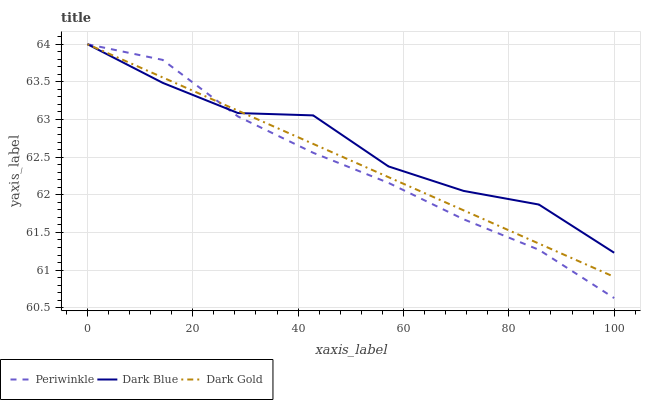Does Periwinkle have the minimum area under the curve?
Answer yes or no. Yes. Does Dark Blue have the maximum area under the curve?
Answer yes or no. Yes. Does Dark Gold have the minimum area under the curve?
Answer yes or no. No. Does Dark Gold have the maximum area under the curve?
Answer yes or no. No. Is Dark Gold the smoothest?
Answer yes or no. Yes. Is Dark Blue the roughest?
Answer yes or no. Yes. Is Periwinkle the smoothest?
Answer yes or no. No. Is Periwinkle the roughest?
Answer yes or no. No. Does Periwinkle have the lowest value?
Answer yes or no. Yes. Does Dark Gold have the lowest value?
Answer yes or no. No. Does Dark Gold have the highest value?
Answer yes or no. Yes. Does Dark Blue intersect Dark Gold?
Answer yes or no. Yes. Is Dark Blue less than Dark Gold?
Answer yes or no. No. Is Dark Blue greater than Dark Gold?
Answer yes or no. No. 